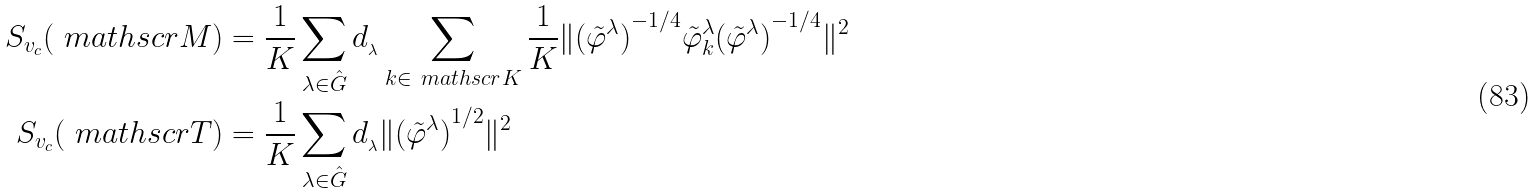Convert formula to latex. <formula><loc_0><loc_0><loc_500><loc_500>S _ { v _ { c } } ( \ m a t h s c r { M } ) & = \frac { 1 } { K } \sum _ { \lambda \in \hat { G } } d _ { _ { \lambda } } \sum _ { k \in \ m a t h s c r { K } } \frac { 1 } { K } \| { ( \tilde { \varphi } ^ { \lambda } ) } ^ { - 1 / 4 } \tilde { \varphi } ^ { \lambda } _ { k } { ( \tilde { \varphi } ^ { \lambda } ) } ^ { - 1 / 4 } { \| } ^ { 2 } \\ S _ { v _ { c } } ( \ m a t h s c r { T } ) & = \frac { 1 } { K } \sum _ { \lambda \in \hat { G } } d _ { _ { \lambda } } \| { ( \tilde { \varphi } ^ { \lambda } ) } ^ { 1 / 2 } { \| } ^ { 2 }</formula> 